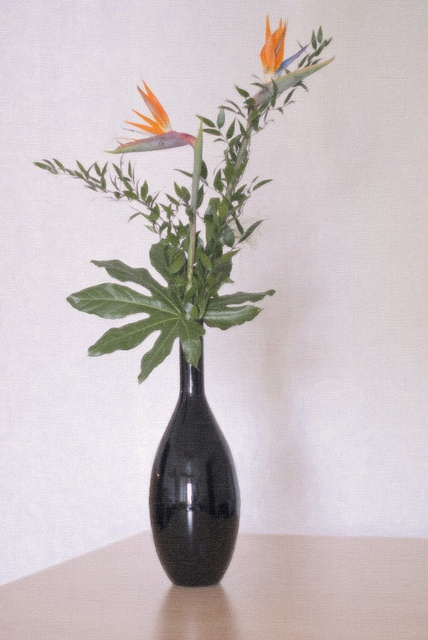Describe the objects in this image and their specific colors. I can see a vase in lavender, black, and gray tones in this image. 